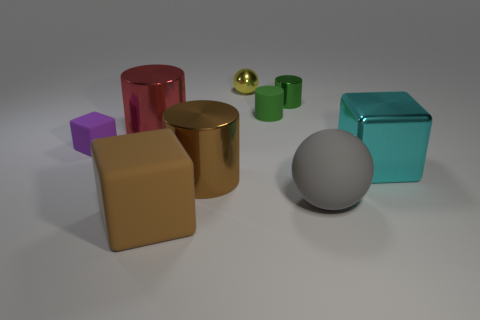There is a tiny rubber object left of the large metallic object that is on the left side of the big matte block; what is its color?
Your answer should be very brief. Purple. There is a large cyan metal cube; what number of shiny cylinders are in front of it?
Offer a very short reply. 1. The large shiny cube has what color?
Your answer should be compact. Cyan. How many tiny things are either purple objects or purple metal spheres?
Provide a short and direct response. 1. Is the color of the big matte object that is to the left of the small green matte object the same as the shiny cylinder behind the small matte cylinder?
Provide a succinct answer. No. How many other things are the same color as the big sphere?
Keep it short and to the point. 0. The tiny shiny object that is behind the green shiny object has what shape?
Offer a very short reply. Sphere. Is the number of large brown cylinders less than the number of big shiny things?
Ensure brevity in your answer.  Yes. Are the large cube that is behind the large gray matte ball and the big brown cylinder made of the same material?
Provide a succinct answer. Yes. Are there any other things that are the same size as the gray matte thing?
Keep it short and to the point. Yes. 